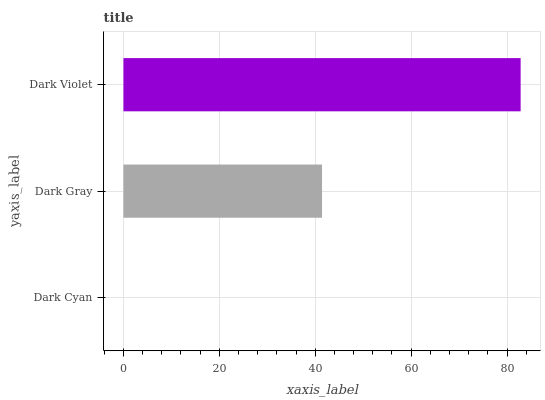Is Dark Cyan the minimum?
Answer yes or no. Yes. Is Dark Violet the maximum?
Answer yes or no. Yes. Is Dark Gray the minimum?
Answer yes or no. No. Is Dark Gray the maximum?
Answer yes or no. No. Is Dark Gray greater than Dark Cyan?
Answer yes or no. Yes. Is Dark Cyan less than Dark Gray?
Answer yes or no. Yes. Is Dark Cyan greater than Dark Gray?
Answer yes or no. No. Is Dark Gray less than Dark Cyan?
Answer yes or no. No. Is Dark Gray the high median?
Answer yes or no. Yes. Is Dark Gray the low median?
Answer yes or no. Yes. Is Dark Cyan the high median?
Answer yes or no. No. Is Dark Cyan the low median?
Answer yes or no. No. 